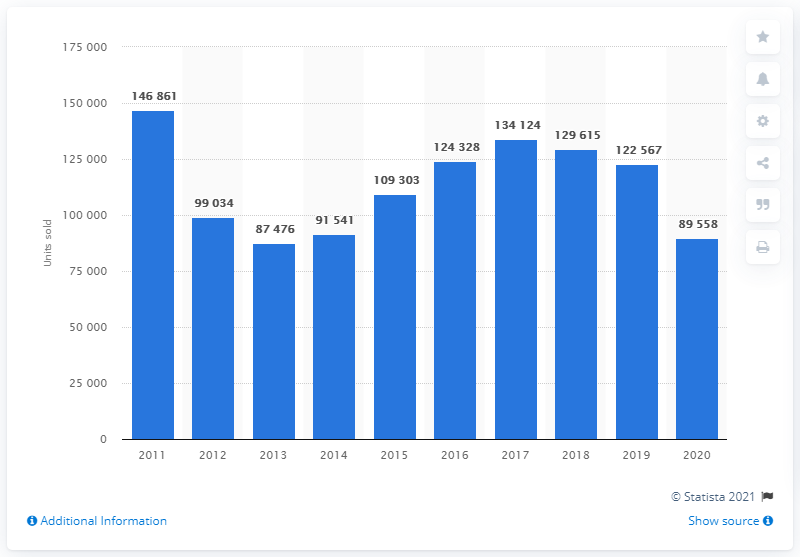List a handful of essential elements in this visual. In 2013, the sales volume of Ford cars in Italy reached the lowest point. 